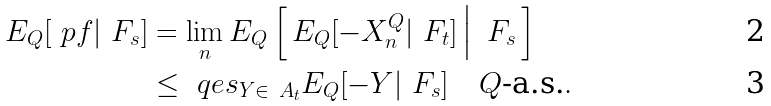<formula> <loc_0><loc_0><loc_500><loc_500>E _ { Q } [ \ p f | \ F _ { s } ] & = \lim _ { n } E _ { Q } \left [ \, E _ { Q } [ - X _ { n } ^ { Q } | \ F _ { t } ] \, \Big | \, \ F _ { s } \, \right ] \\ & \leq \ q e s _ { Y \in \ A _ { t } } E _ { Q } [ - Y | \ F _ { s } ] \quad Q \text {-a.s.} .</formula> 